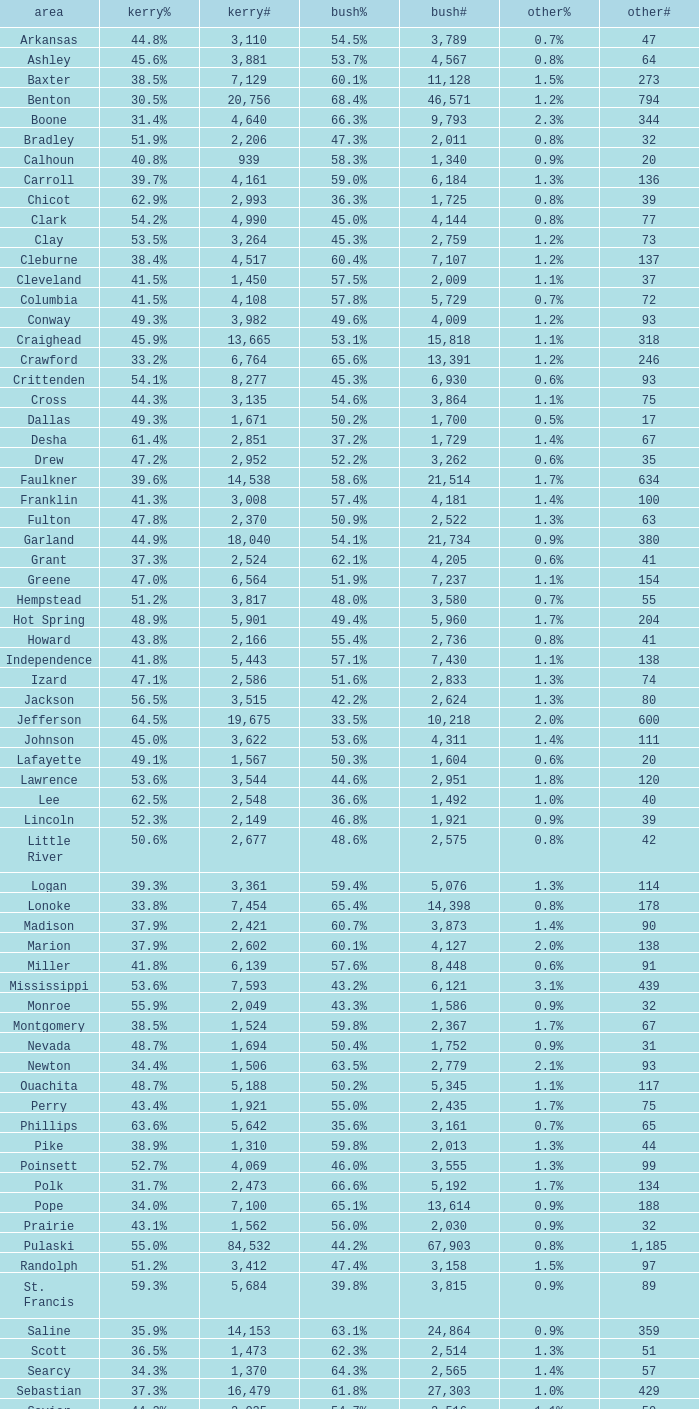What is the lowest Bush#, when Bush% is "65.4%"? 14398.0. 